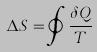Convert formula to latex. <formula><loc_0><loc_0><loc_500><loc_500>\Delta S = \oint \frac { \delta Q } { T }</formula> 